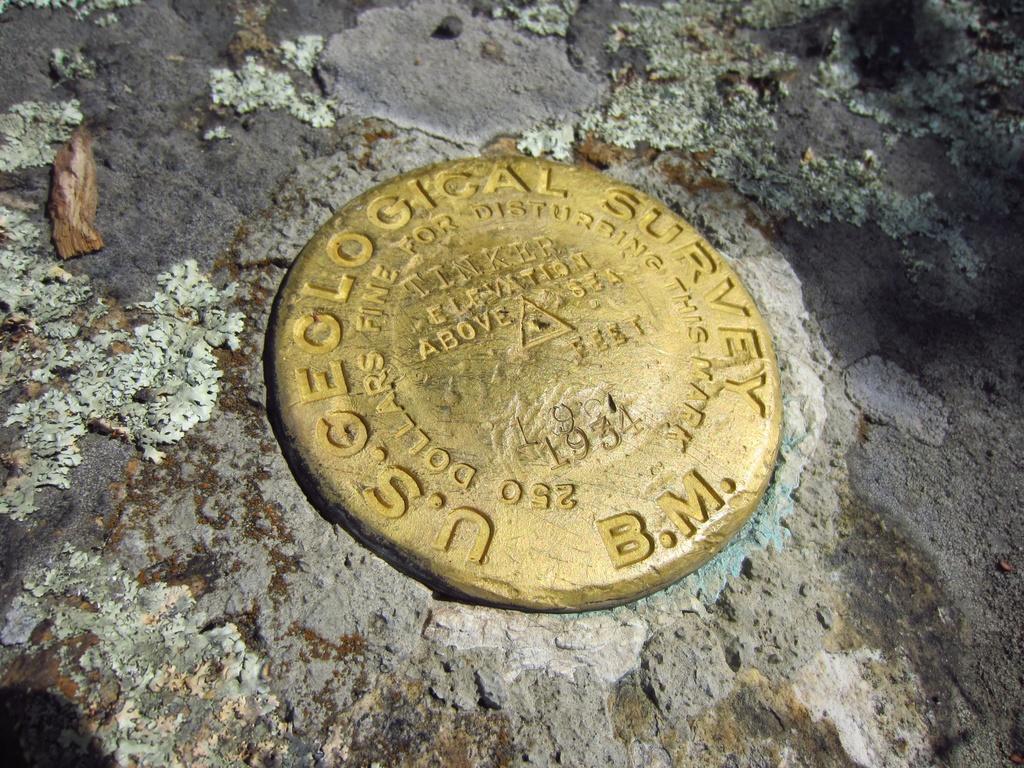What kind of survey is shown?
Keep it short and to the point. Geological. 